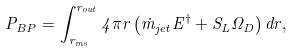<formula> <loc_0><loc_0><loc_500><loc_500>P _ { B P } = \int _ { r _ { m s } } ^ { r _ { o u t } } { 4 \pi r \left ( { \dot { m } _ { j e t } E ^ { \dag } + S _ { L } \Omega _ { D } } \right ) d r } ,</formula> 